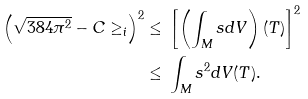Convert formula to latex. <formula><loc_0><loc_0><loc_500><loc_500>\left ( \sqrt { 3 8 4 \pi ^ { 2 } } - C \geq _ { i } \right ) ^ { 2 } \leq & \ \left [ \left ( \int _ { M } s d V \right ) ( T ) \right ] ^ { 2 } \\ \leq & \ \int _ { M } s ^ { 2 } d V ( T ) .</formula> 